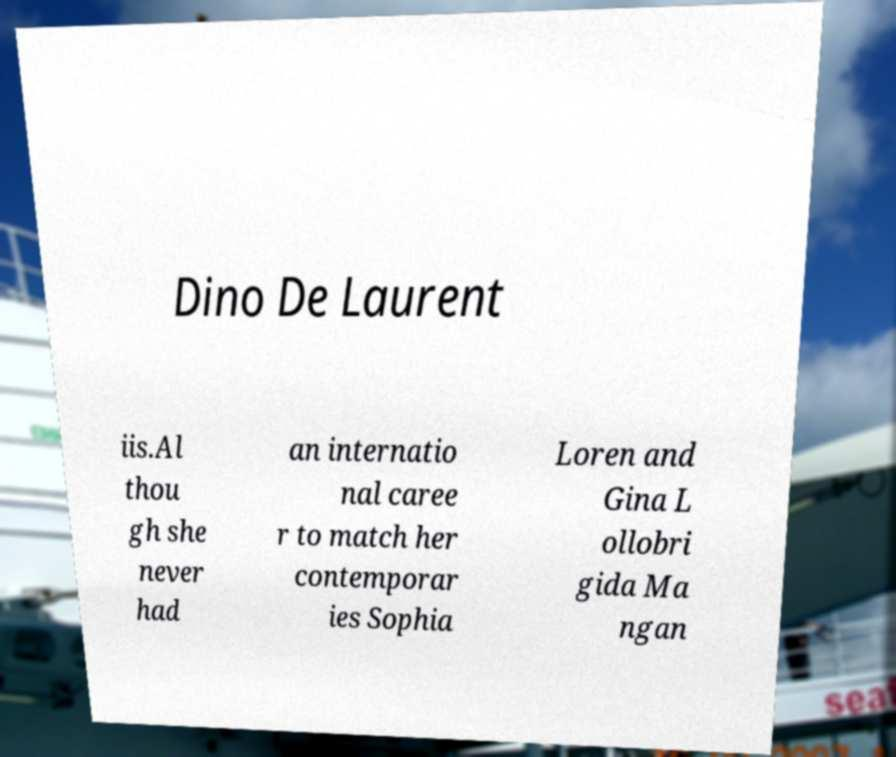Could you assist in decoding the text presented in this image and type it out clearly? Dino De Laurent iis.Al thou gh she never had an internatio nal caree r to match her contemporar ies Sophia Loren and Gina L ollobri gida Ma ngan 